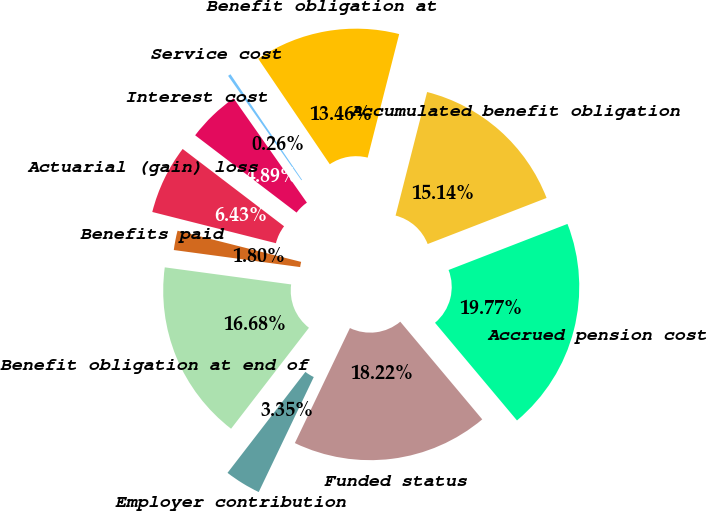Convert chart to OTSL. <chart><loc_0><loc_0><loc_500><loc_500><pie_chart><fcel>Accumulated benefit obligation<fcel>Benefit obligation at<fcel>Service cost<fcel>Interest cost<fcel>Actuarial (gain) loss<fcel>Benefits paid<fcel>Benefit obligation at end of<fcel>Employer contribution<fcel>Funded status<fcel>Accrued pension cost<nl><fcel>15.14%<fcel>13.46%<fcel>0.26%<fcel>4.89%<fcel>6.43%<fcel>1.8%<fcel>16.68%<fcel>3.35%<fcel>18.22%<fcel>19.77%<nl></chart> 